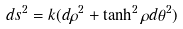<formula> <loc_0><loc_0><loc_500><loc_500>d s ^ { 2 } = k ( d \rho ^ { 2 } + \tanh ^ { 2 } \rho d \theta ^ { 2 } )</formula> 